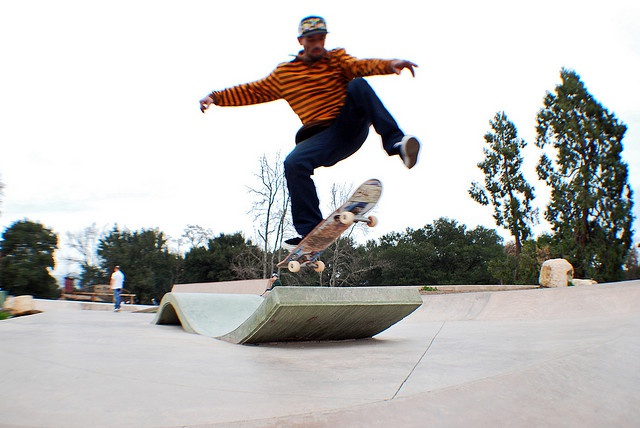Describe the objects in this image and their specific colors. I can see people in white, black, and maroon tones, skateboard in white, darkgray, gray, and maroon tones, people in white, lavender, blue, and gray tones, bench in white, black, gray, salmon, and maroon tones, and people in white, black, gray, teal, and navy tones in this image. 